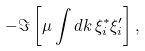Convert formula to latex. <formula><loc_0><loc_0><loc_500><loc_500>- \Im \left [ \mu \int d k \, \xi ^ { * } _ { i } \xi ^ { \prime } _ { i } \right ] ,</formula> 